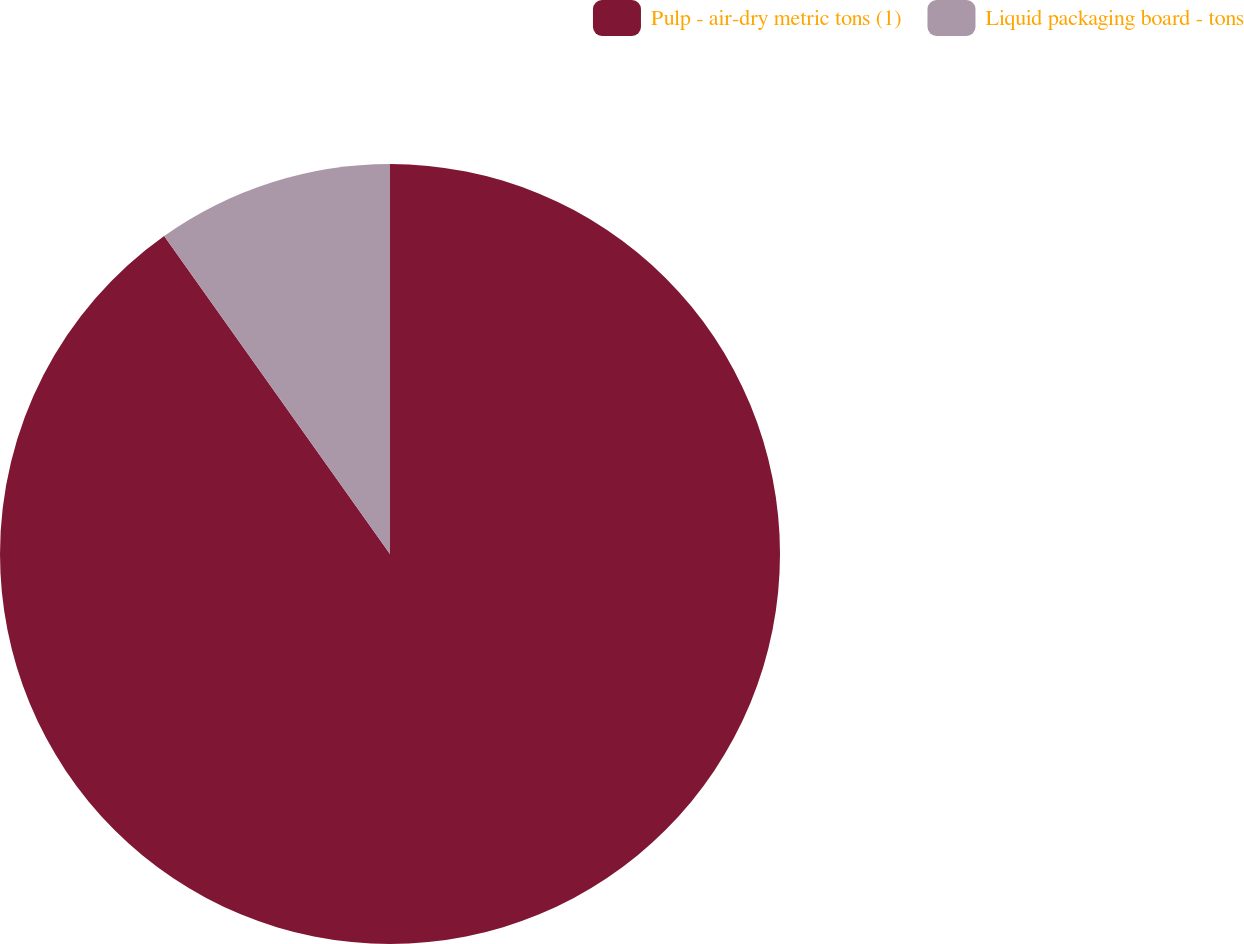Convert chart. <chart><loc_0><loc_0><loc_500><loc_500><pie_chart><fcel>Pulp - air-dry metric tons (1)<fcel>Liquid packaging board - tons<nl><fcel>90.17%<fcel>9.83%<nl></chart> 